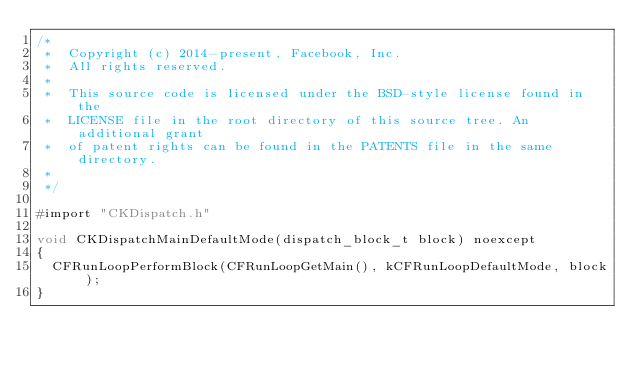<code> <loc_0><loc_0><loc_500><loc_500><_ObjectiveC_>/*
 *  Copyright (c) 2014-present, Facebook, Inc.
 *  All rights reserved.
 *
 *  This source code is licensed under the BSD-style license found in the
 *  LICENSE file in the root directory of this source tree. An additional grant
 *  of patent rights can be found in the PATENTS file in the same directory.
 *
 */

#import "CKDispatch.h"

void CKDispatchMainDefaultMode(dispatch_block_t block) noexcept
{
  CFRunLoopPerformBlock(CFRunLoopGetMain(), kCFRunLoopDefaultMode, block);
}
</code> 